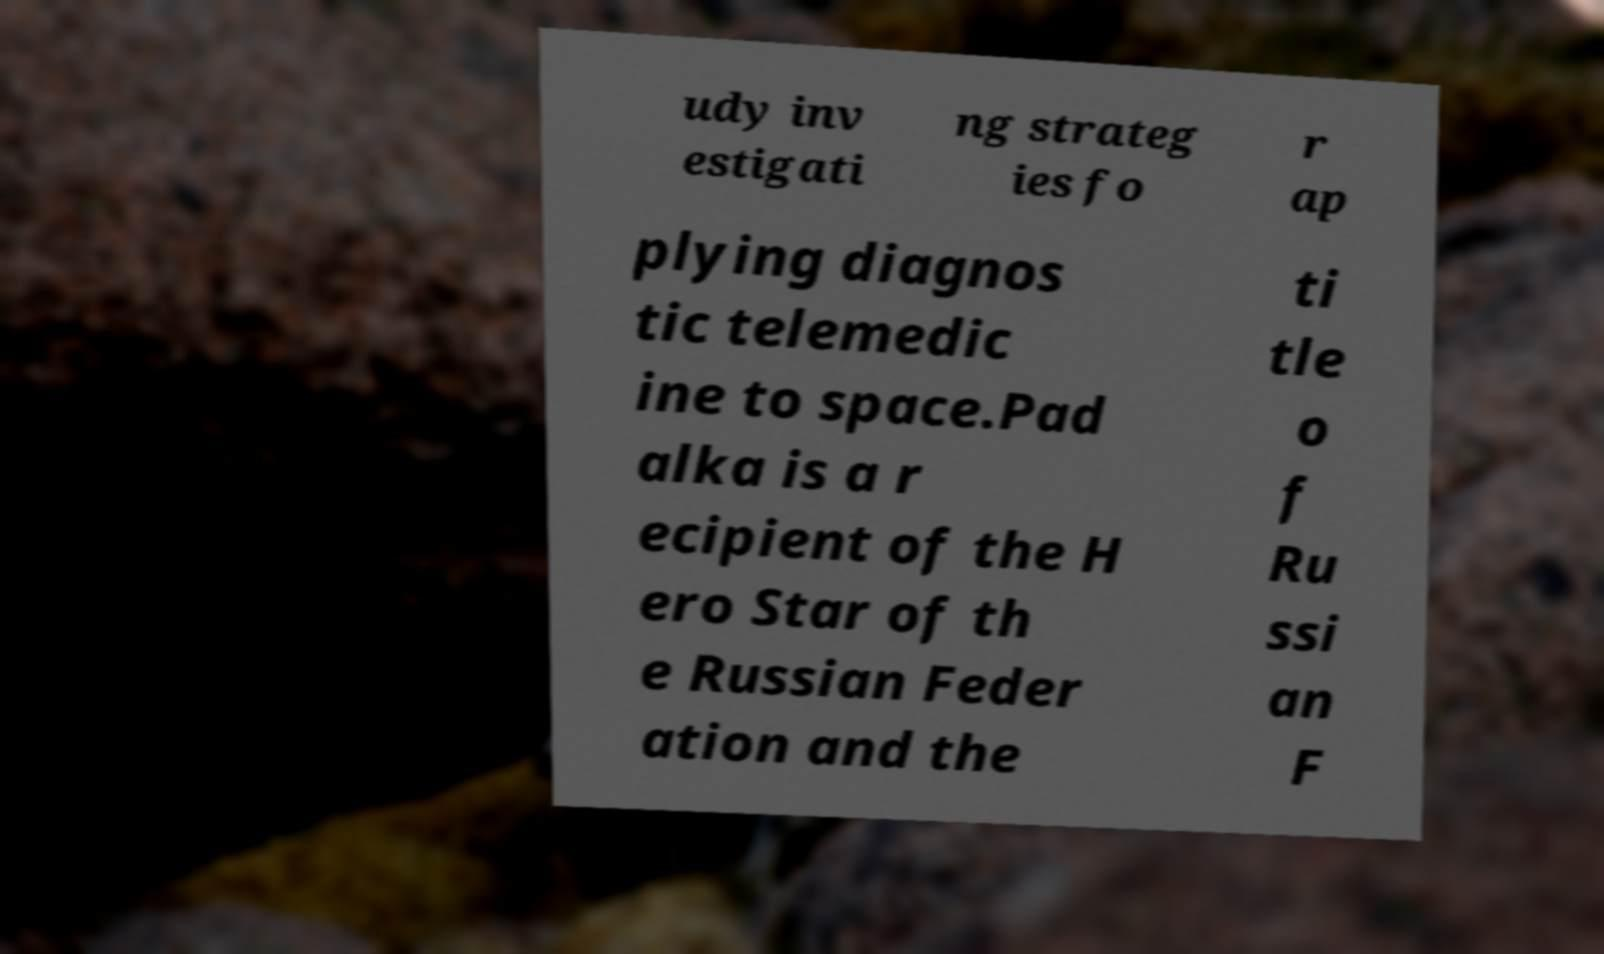I need the written content from this picture converted into text. Can you do that? udy inv estigati ng strateg ies fo r ap plying diagnos tic telemedic ine to space.Pad alka is a r ecipient of the H ero Star of th e Russian Feder ation and the ti tle o f Ru ssi an F 